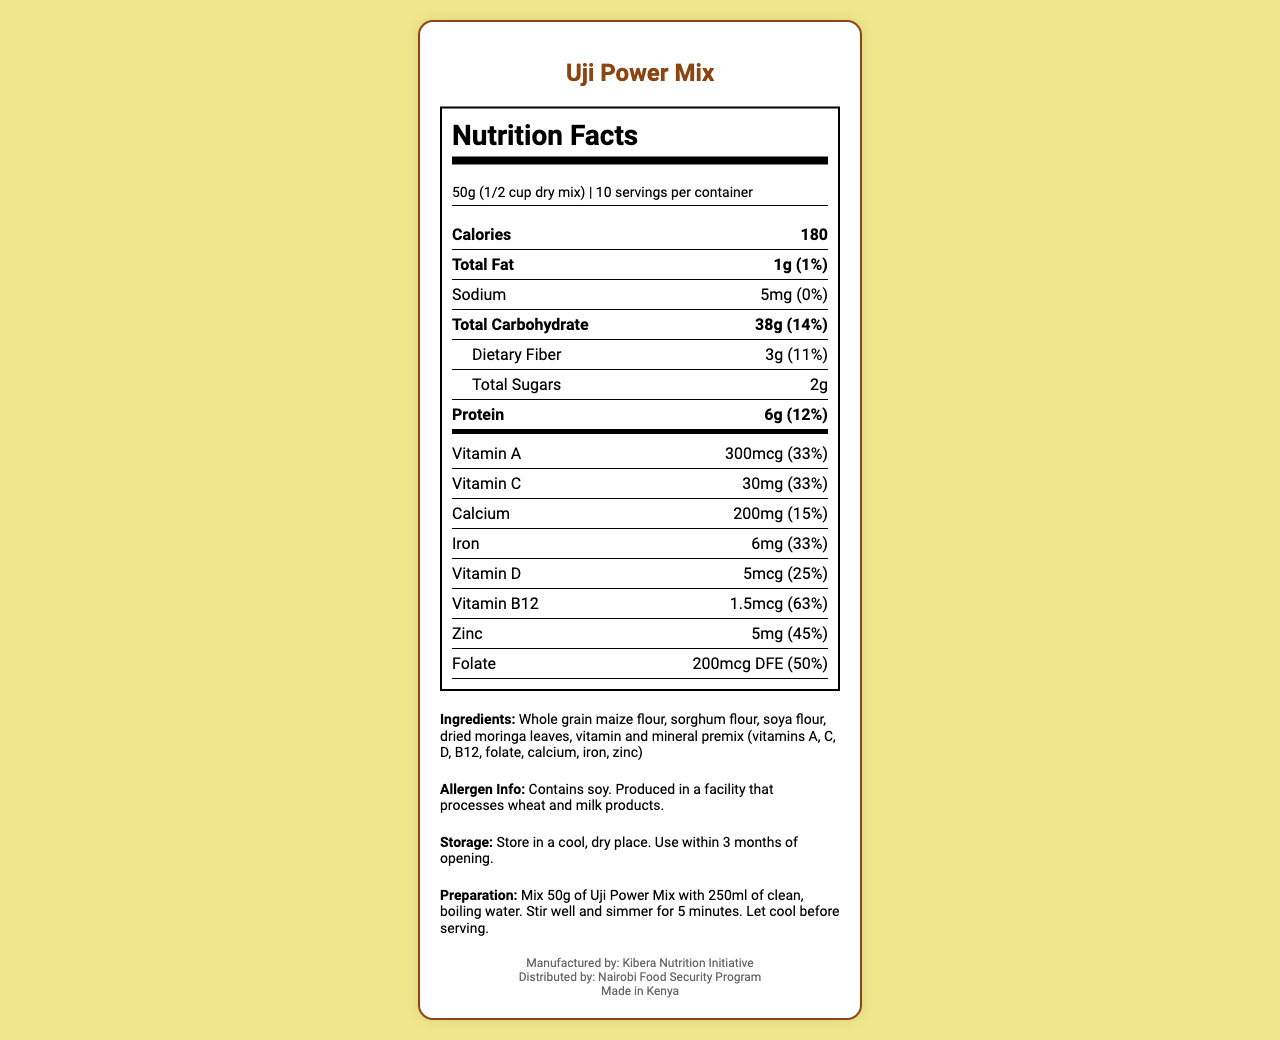who is the manufacturer of the product? The footer of the document clearly states that the product is manufactured by Kibera Nutrition Initiative.
Answer: Kibera Nutrition Initiative what is the serving size for Uji Power Mix? The serving size is listed near the top of the document as "50g (1/2 cup dry mix)."
Answer: 50g (1/2 cup dry mix) how much protein is in one serving? The nutrition label indicates that there are 6g of protein per serving.
Answer: 6g what allergens are mentioned for Uji Power Mix? The allergen information section mentions that the product contains soy.
Answer: Soy how much iron is provided in one serving, in terms of daily value percentage? The vitamin and mineral section shows that one serving provides 33% of the daily value for iron.
Answer: 33% how many servings are there in one container? A. 5 B. 10 C. 15 D. 20 The serving information mentions "10 servings per container."
Answer: B what is the total carbohydrate content per serving, including the daily value percentage? A. 13g (5%) B. 38g (14%) C. 25g (8%) D. 50g (20%) The nutrition label shows 38g of carbohydrates per serving with a daily value of 14%.
Answer: B does Uji Power Mix contain Vitamin B12? The vitamin and mineral section lists VItamin B12 with 63% of the daily value.
Answer: Yes summarize the key nutritional information of Uji Power Mix. The summary covers the main nutritional information including calories, major macronutrients, and the various vitamins and minerals provided by the product.
Answer: Uji Power Mix contains 180 calories per 50g serving. It has low total fat (1g) and sodium (5mg), but is high in carbohydrates (38g) and dietary fiber (3g). It includes a variety of vitamins and minerals such as Vitamin A, C, D, B12, calcium, iron, and zinc. what is the shelf life after opening Uji Power Mix? The storage instructions mention that the product should be used within 3 months of opening.
Answer: 3 months what temperature should Uji Power Mix be stored at? The storage instructions state to store the product in a cool, dry place.
Answer: In a cool, dry place how long should Uji Power Mix be simmered during preparation? The preparation instructions specify that the mix should be simmered for 5 minutes.
Answer: 5 minutes what is the sodium content in a serving? The nutrition label shows that each serving contains 5mg of sodium.
Answer: 5mg which vitamin has the highest daily value percentage in one serving? The vitamin and mineral section shows that Vitamin B12 has the highest daily value percentage with 63%.
Answer: Vitamin B12 (63%) what type of flour is NOT in Uji Power Mix? A. Whole grain maize flour B. Wheat flour C. Sorghum flour D. Soya flour The ingredients list includes whole grain maize flour, sorghum flour, and soya flour, but not wheat flour.
Answer: B what is the main source of carbohydrates in Uji Power Mix? The ingredients section lists whole grain maize flour and sorghum flour, which are common sources of carbohydrates.
Answer: Whole grain maize flour, sorghum flour how is the mix prepared before serving? The preparation instructions detail the steps to mix, boil, simmer, and cool the product before serving.
Answer: Mix 50g of Uji Power Mix with 250ml of clean, boiling water. Stir well and simmer for 5 minutes. Let cool before serving. is there any information about the sourcing of the ingredients? The document does not provide any specific information about the sourcing of the ingredients.
Answer: No who distributes Uji Power Mix? The footer mentions that the product is distributed by Nairobi Food Security Program.
Answer: Nairobi Food Security Program 